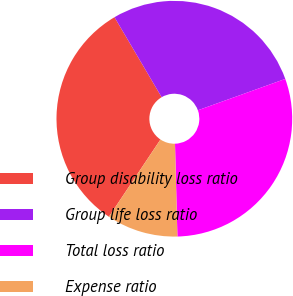Convert chart to OTSL. <chart><loc_0><loc_0><loc_500><loc_500><pie_chart><fcel>Group disability loss ratio<fcel>Group life loss ratio<fcel>Total loss ratio<fcel>Expense ratio<nl><fcel>32.15%<fcel>27.99%<fcel>30.07%<fcel>9.78%<nl></chart> 